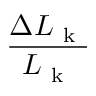Convert formula to latex. <formula><loc_0><loc_0><loc_500><loc_500>\frac { \Delta L _ { k } } { L _ { k } }</formula> 